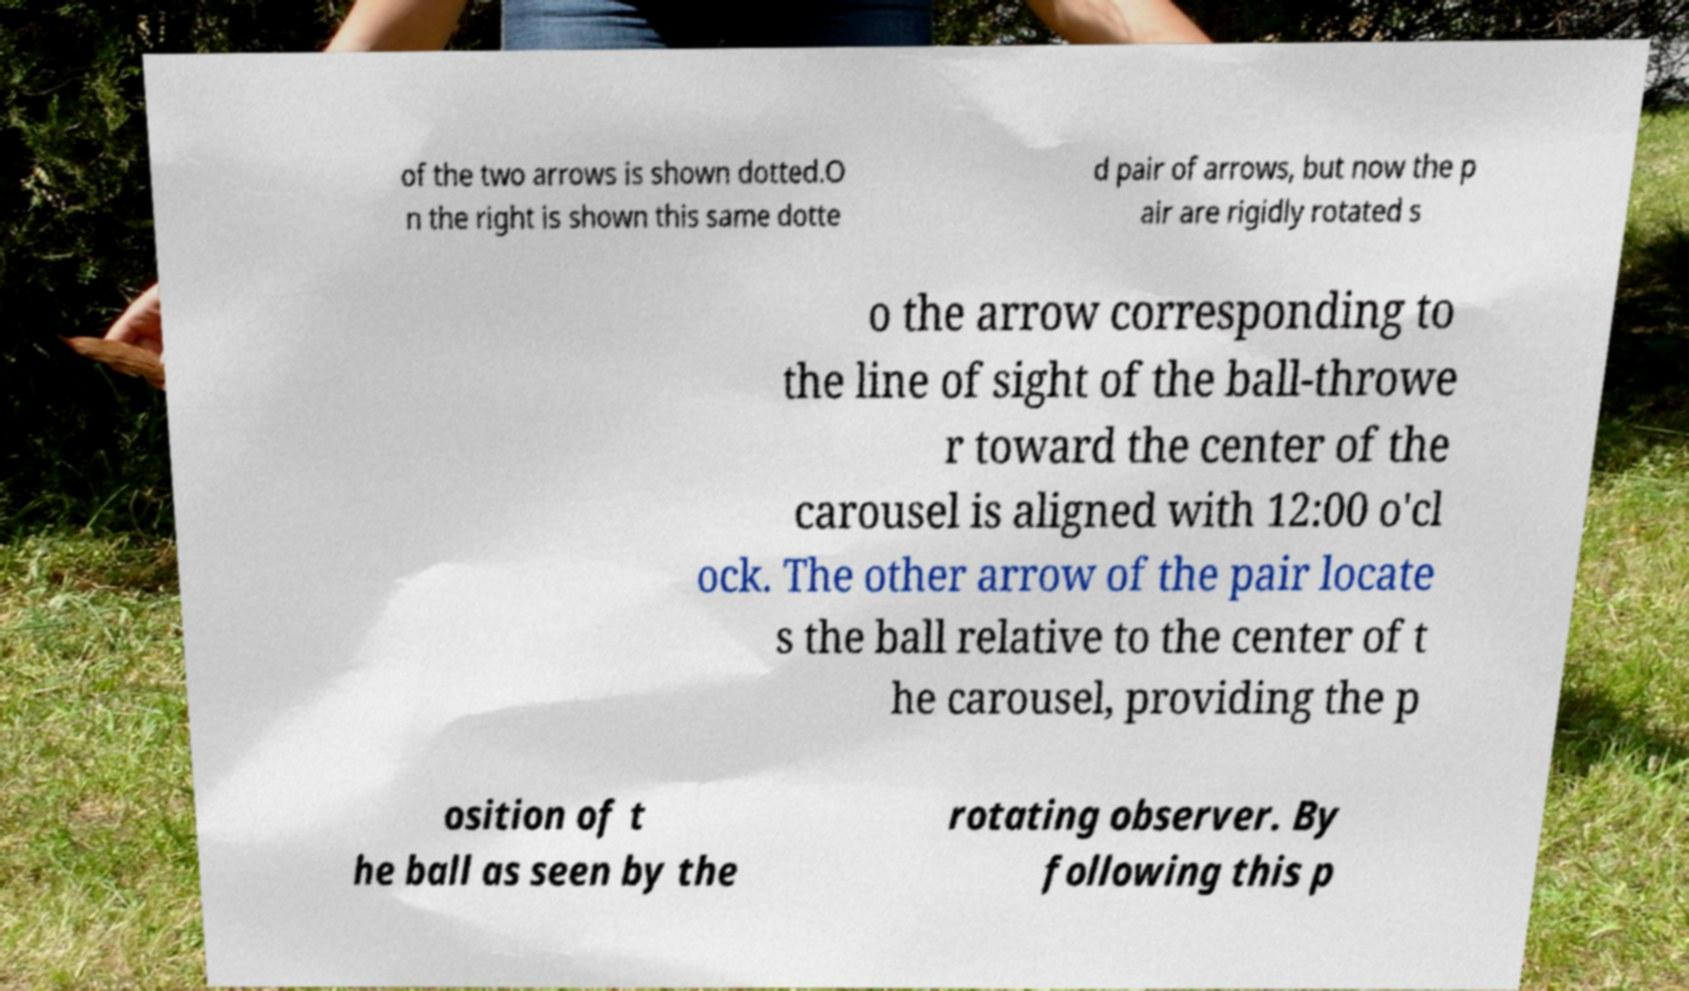For documentation purposes, I need the text within this image transcribed. Could you provide that? of the two arrows is shown dotted.O n the right is shown this same dotte d pair of arrows, but now the p air are rigidly rotated s o the arrow corresponding to the line of sight of the ball-throwe r toward the center of the carousel is aligned with 12:00 o'cl ock. The other arrow of the pair locate s the ball relative to the center of t he carousel, providing the p osition of t he ball as seen by the rotating observer. By following this p 